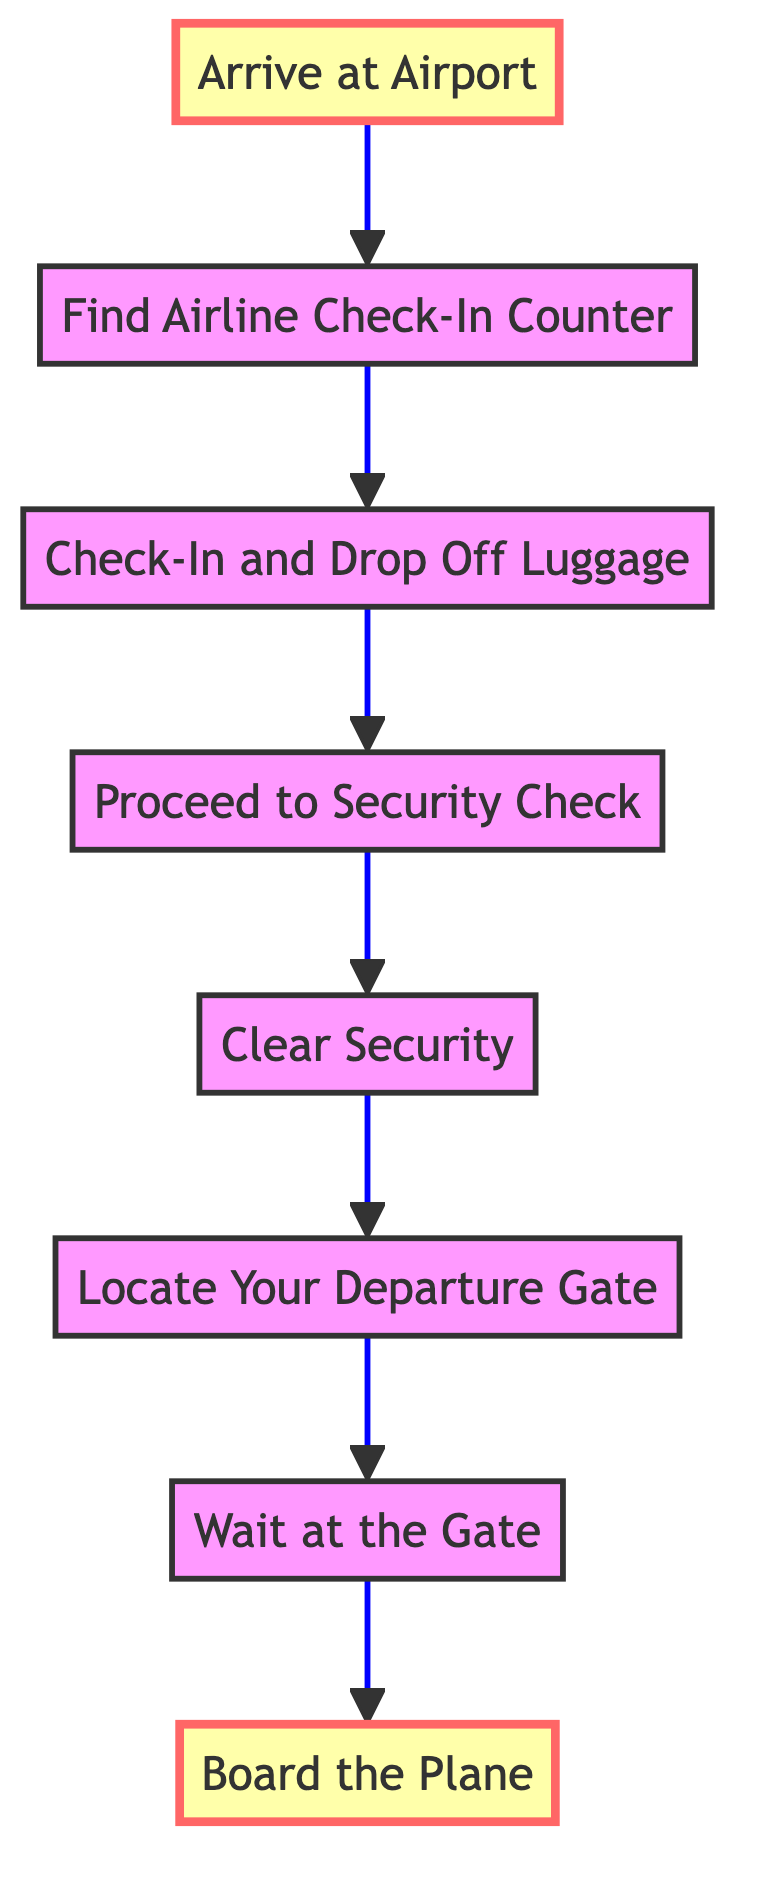What is the first step after arriving at the airport? The first step in the diagram after arriving at the airport is to find the airline check-in counter (B). This is a direct continuation from the first node (A) to the next node (B) in the flow chart.
Answer: Find Airline Check-In Counter How many steps are there in total from check-in to boarding? The diagram illustrates eight distinct steps from Arriving at Airport (A) to Boarding the Plane (H). This includes each labeled node in the flow from bottom to top.
Answer: 8 What do you need to present at check-in? During check-in, it is essential to present your passport and booking information. This requirement is specifically detailed under the Check-In and Drop Off Luggage node (C).
Answer: Passport and booking information What is the action required before locating your departure gate? Before proceeding to locate your departure gate, you must first clear security. This is indicated in the flow of steps between the nodes, showing the necessity of clearing security (E) before locating the gate (F).
Answer: Clear Security What is the last step in the airport navigation process? The final step in the flow chart is boarding the plane (H). This is explicitly stated as the endpoint in the instruction flow, highlighting the last action that needs to be taken in this series of steps.
Answer: Board the Plane What must you do after waiting at the gate? After waiting at the gate (G), you should board the plane (H) when your boarding group is called. This sequential relationship is clear in the flow chart, showing that the latter action directly follows the former.
Answer: Board the Plane What item must you provide at the security check? At the security check, you need to present your boarding pass and ID. This requirement is made explicitly evident in the Proceed to Security Check node (D) within the diagram, showing what documents are necessary for that step.
Answer: Boarding pass and ID Which step follows the clear security step? The step following Clear Security (E) is Locating Your Departure Gate (F). This direct relationship is shown in the sequential flow from one node to the other, indicating the order of actions in the airport navigation process.
Answer: Locate Your Departure Gate 